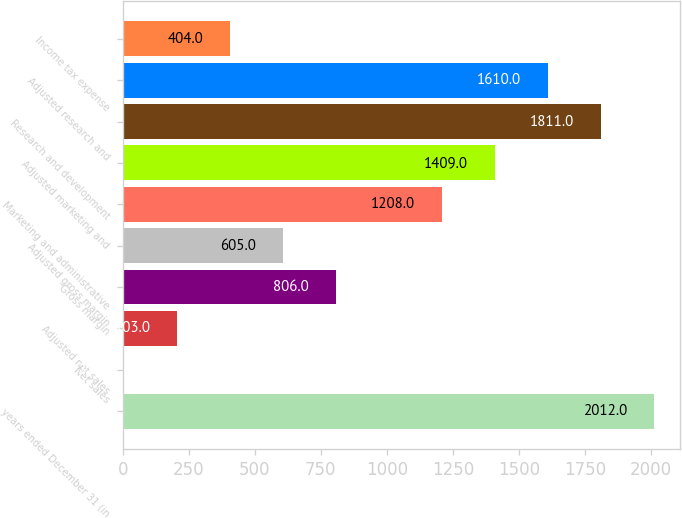Convert chart. <chart><loc_0><loc_0><loc_500><loc_500><bar_chart><fcel>years ended December 31 (in<fcel>Net sales<fcel>Adjusted net sales<fcel>Gross margin<fcel>Adjusted gross margin<fcel>Marketing and administrative<fcel>Adjusted marketing and<fcel>Research and development<fcel>Adjusted research and<fcel>Income tax expense<nl><fcel>2012<fcel>2<fcel>203<fcel>806<fcel>605<fcel>1208<fcel>1409<fcel>1811<fcel>1610<fcel>404<nl></chart> 